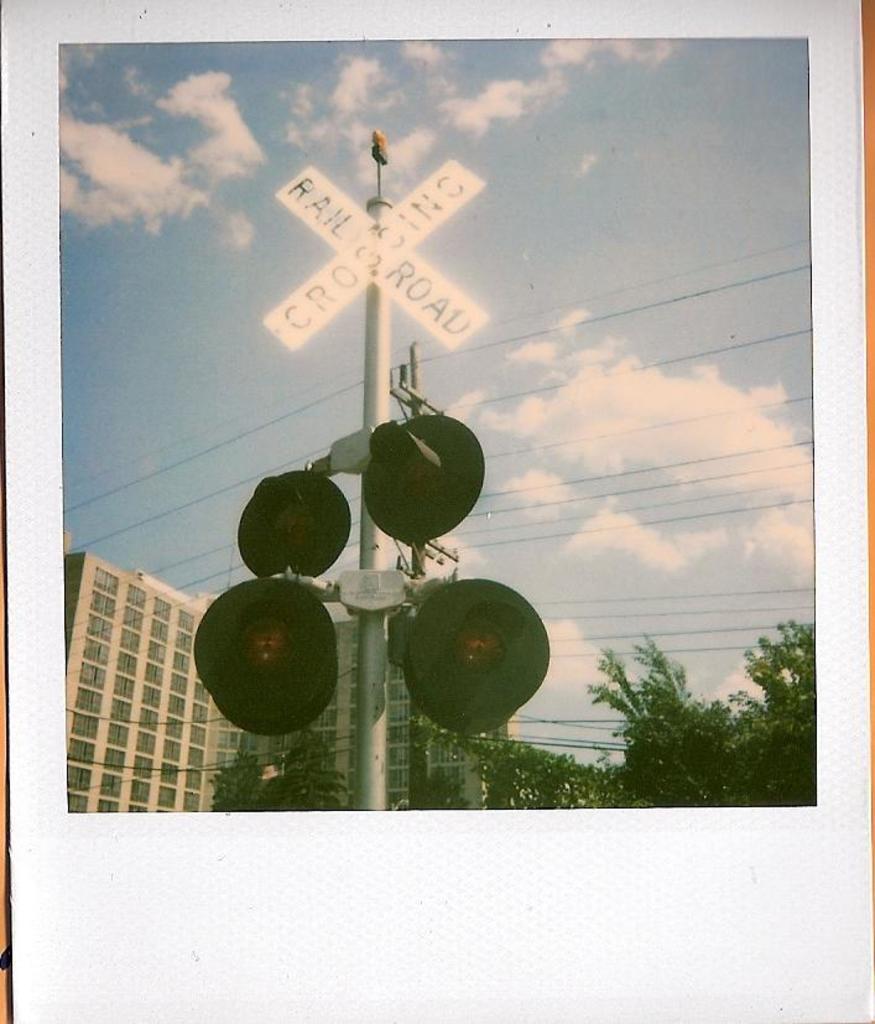Describe this image in one or two sentences. In this image there is a photo. In the photo there is a pole. To the pole there are sign boards and lights. Behind it there are buildings and trees. At the top there is the sky. 